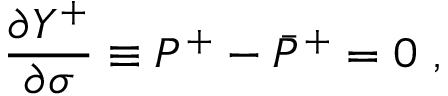<formula> <loc_0><loc_0><loc_500><loc_500>\frac { \partial Y ^ { + } } { \partial \sigma } \equiv P ^ { + } - \bar { P } ^ { + } = 0 ,</formula> 